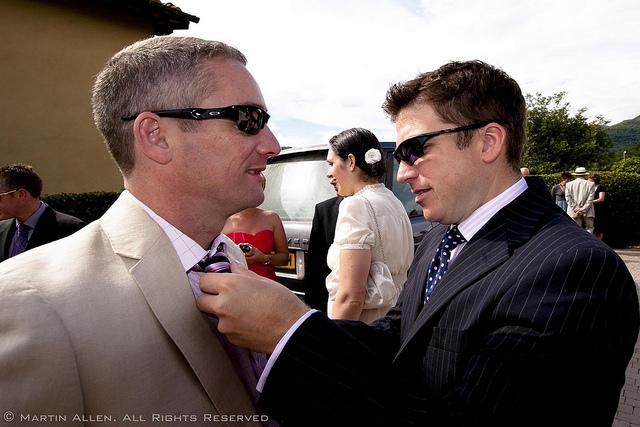What type of clothes are the people wearing?
Keep it brief. Suits. Are the men wearing sunglasses?
Short answer required. Yes. Are the men in the foreground dressed up?
Give a very brief answer. Yes. 